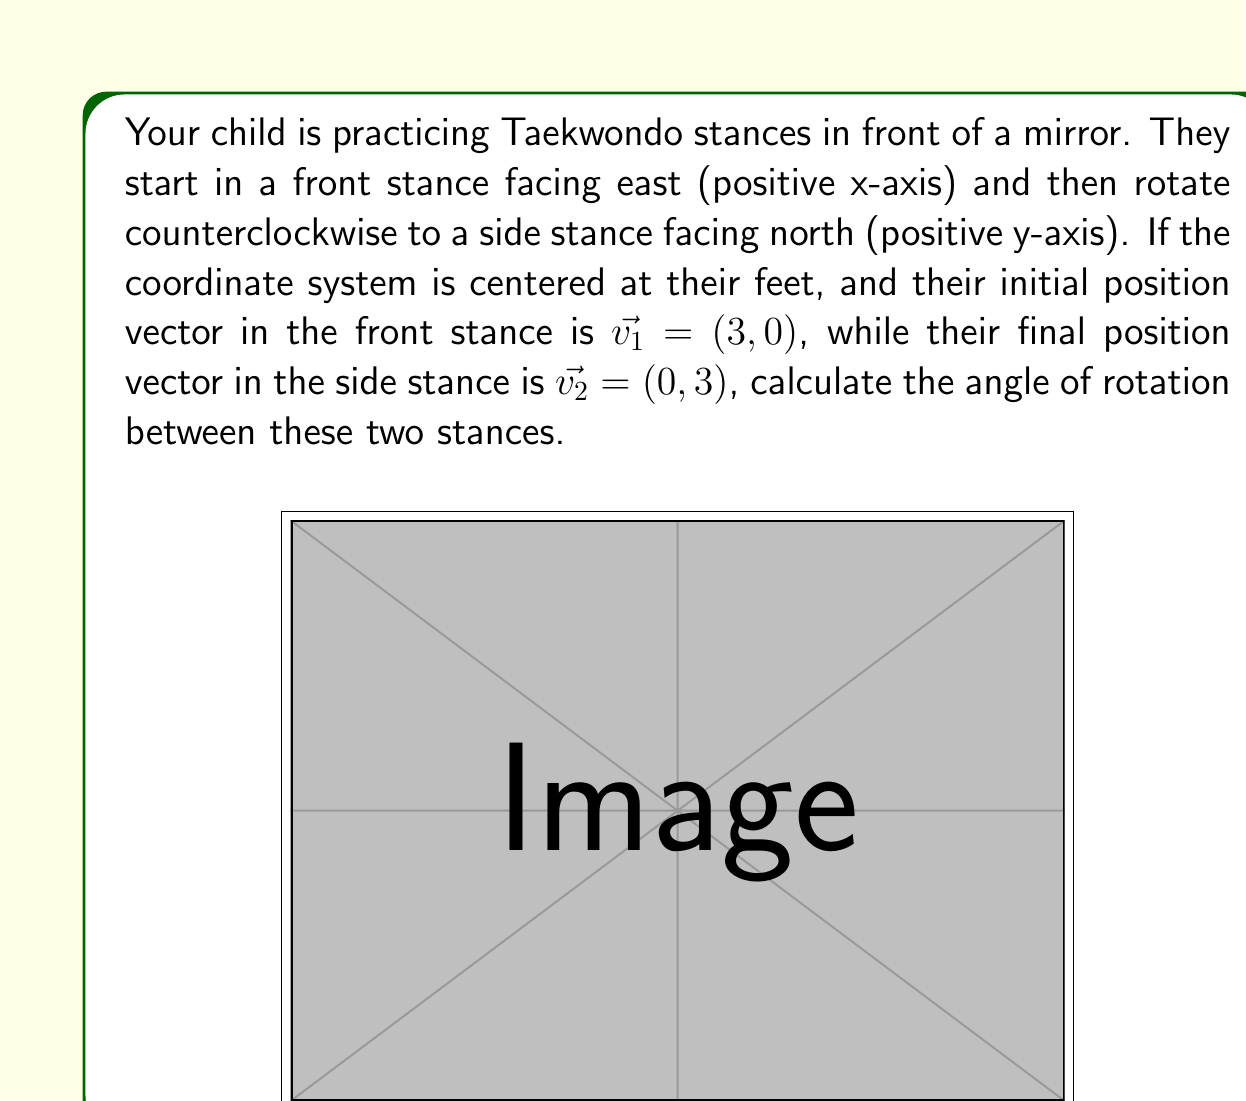Solve this math problem. To solve this problem, we can use the dot product formula to find the angle between two vectors. The formula is:

$$\cos \theta = \frac{\vec{v_1} \cdot \vec{v_2}}{|\vec{v_1}||\vec{v_2}|}$$

Where $\theta$ is the angle between the vectors, $\vec{v_1} \cdot \vec{v_2}$ is the dot product, and $|\vec{v_1}|$ and $|\vec{v_2}|$ are the magnitudes of the vectors.

Step 1: Calculate the dot product
$\vec{v_1} \cdot \vec{v_2} = (3)(0) + (0)(3) = 0$

Step 2: Calculate the magnitudes
$|\vec{v_1}| = \sqrt{3^2 + 0^2} = 3$
$|\vec{v_2}| = \sqrt{0^2 + 3^2} = 3$

Step 3: Substitute into the formula
$$\cos \theta = \frac{0}{(3)(3)} = 0$$

Step 4: Solve for $\theta$
$$\theta = \arccos(0)$$

The $\arccos(0)$ is equal to $\frac{\pi}{2}$ radians or 90 degrees.

Therefore, the angle of rotation between the front stance and the side stance is 90 degrees counterclockwise.
Answer: 90 degrees 